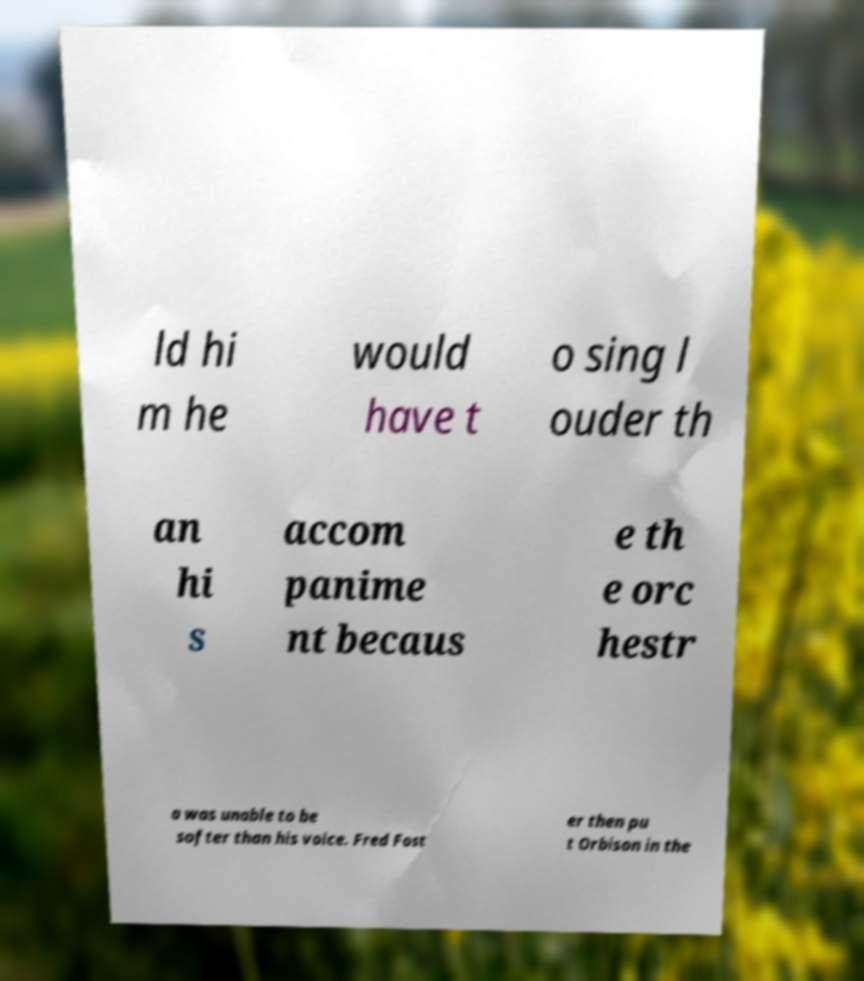What messages or text are displayed in this image? I need them in a readable, typed format. ld hi m he would have t o sing l ouder th an hi s accom panime nt becaus e th e orc hestr a was unable to be softer than his voice. Fred Fost er then pu t Orbison in the 